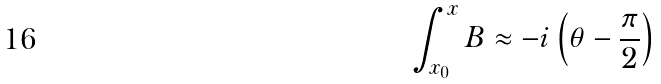Convert formula to latex. <formula><loc_0><loc_0><loc_500><loc_500>\int _ { x _ { 0 } } ^ { x } B \approx - i \left ( \theta - \frac { \pi } { 2 } \right )</formula> 